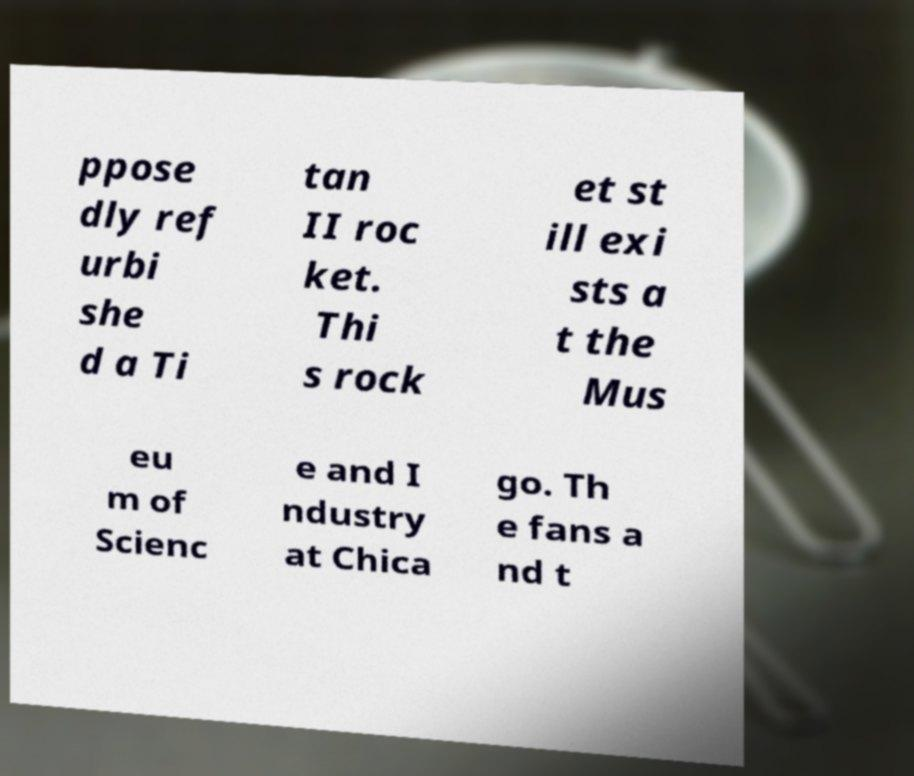For documentation purposes, I need the text within this image transcribed. Could you provide that? ppose dly ref urbi she d a Ti tan II roc ket. Thi s rock et st ill exi sts a t the Mus eu m of Scienc e and I ndustry at Chica go. Th e fans a nd t 